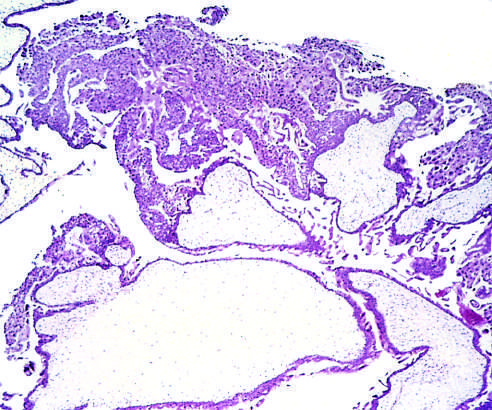re distended hydropic villi and proliferation of the chorionic epithelium evident in this microscopic image?
Answer the question using a single word or phrase. Yes 